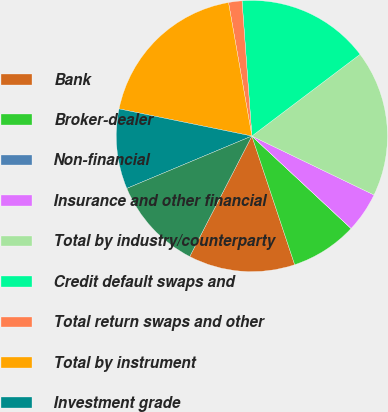Convert chart to OTSL. <chart><loc_0><loc_0><loc_500><loc_500><pie_chart><fcel>Bank<fcel>Broker-dealer<fcel>Non-financial<fcel>Insurance and other financial<fcel>Total by industry/counterparty<fcel>Credit default swaps and<fcel>Total return swaps and other<fcel>Total by instrument<fcel>Investment grade<fcel>Non-investment grade (1)<nl><fcel>12.69%<fcel>7.94%<fcel>0.02%<fcel>4.77%<fcel>17.45%<fcel>15.86%<fcel>1.6%<fcel>19.03%<fcel>9.52%<fcel>11.11%<nl></chart> 